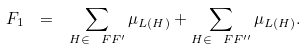<formula> <loc_0><loc_0><loc_500><loc_500>F _ { 1 } \ = \ \sum _ { H \in \ F F ^ { \prime } } \mu _ { L ( H ) } + \sum _ { H \in \ F F ^ { \prime \prime } } \mu _ { L ( H ) } .</formula> 